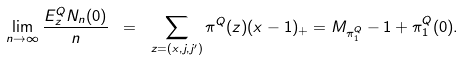Convert formula to latex. <formula><loc_0><loc_0><loc_500><loc_500>\lim _ { n \to \infty } \frac { E ^ { Q } _ { z } N _ { n } ( 0 ) } { n } \ = \ \sum _ { z = ( x , j , j ^ { \prime } ) } \pi ^ { Q } ( z ) ( x - 1 ) _ { + } = M _ { \pi ^ { Q } _ { 1 } } - 1 + \pi ^ { Q } _ { 1 } ( 0 ) .</formula> 